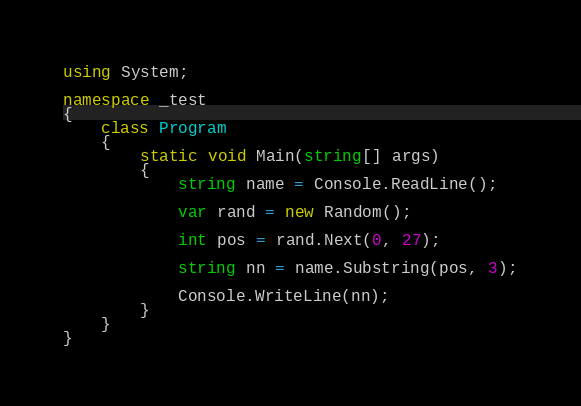<code> <loc_0><loc_0><loc_500><loc_500><_C#_>using System;

namespace _test
{
    class Program
    {
        static void Main(string[] args)
        {
            string name = Console.ReadLine();

            var rand = new Random();

            int pos = rand.Next(0, 27);

            string nn = name.Substring(pos, 3);

            Console.WriteLine(nn);
        }
    }
}
</code> 